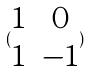<formula> <loc_0><loc_0><loc_500><loc_500>( \begin{matrix} 1 & 0 \\ 1 & - 1 \end{matrix} )</formula> 